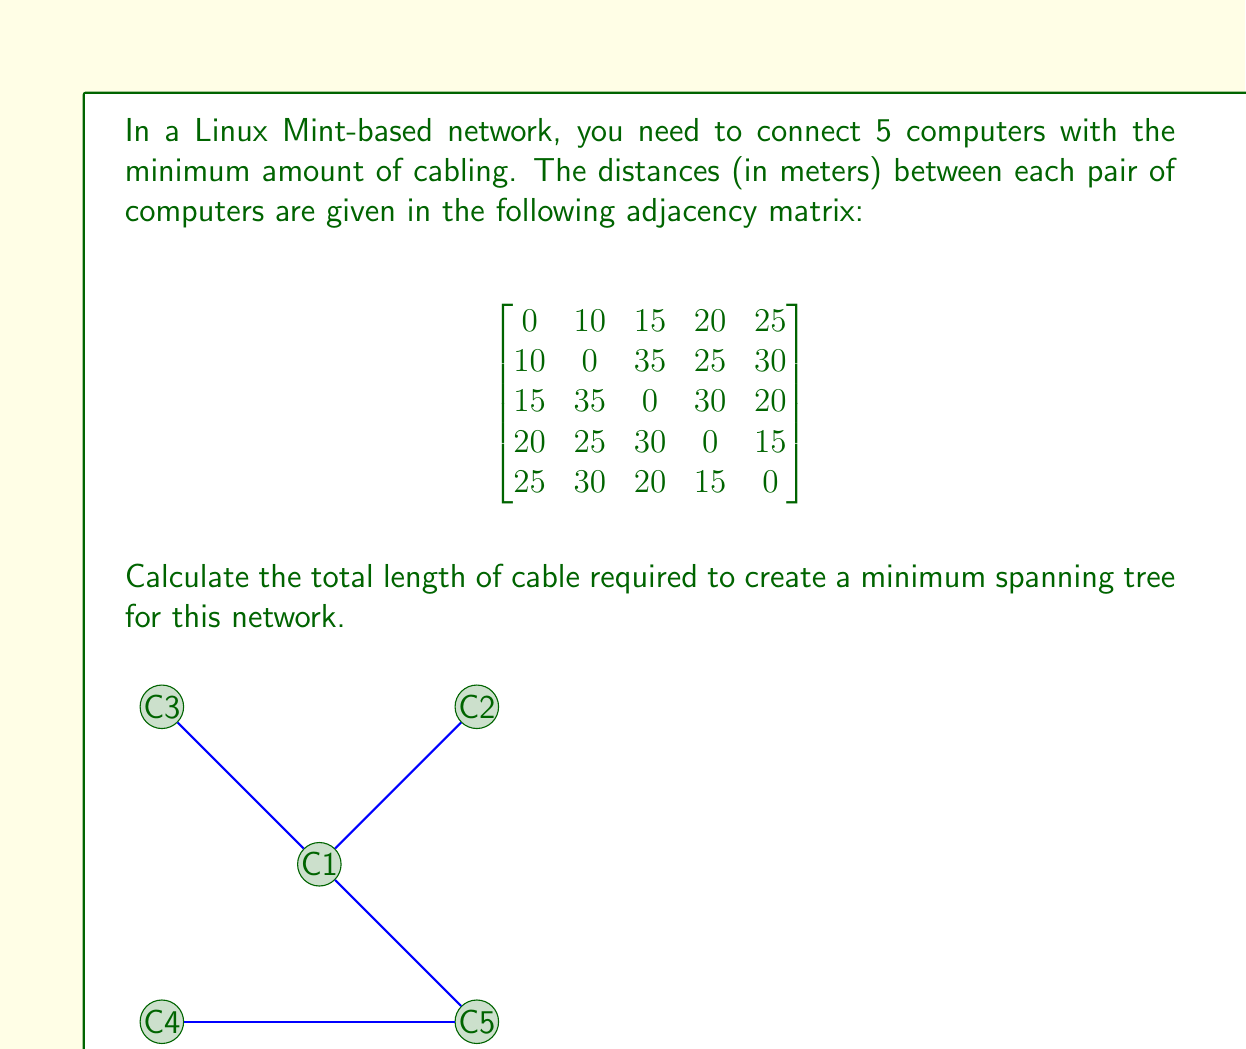Help me with this question. To solve this problem, we'll use Kruskal's algorithm to find the minimum spanning tree (MST) of the network. The algorithm works as follows:

1. Sort all edges in ascending order of weight (distance).
2. Start with an empty MST.
3. For each edge, starting from the smallest:
   a. If adding this edge doesn't create a cycle, add it to the MST.
   b. If it creates a cycle, skip it.
4. Continue until we have $n-1$ edges, where $n$ is the number of nodes.

Let's apply this to our network:

1. Sort the edges:
   C1-C2: 10m
   C1-C3: 15m
   C4-C5: 15m
   C1-C4: 20m
   C3-C5: 20m
   C1-C5: 25m
   C2-C4: 25m
   C2-C5: 30m
   C3-C4: 30m
   C2-C3: 35m

2. Start adding edges:
   - Add C1-C2 (10m)
   - Add C1-C3 (15m)
   - Add C4-C5 (15m)
   - Add C1-C4 (20m)

At this point, we have 4 edges (n-1, where n=5), so we stop.

The minimum spanning tree consists of these edges:
C1-C2, C1-C3, C4-C5, and C1-C4.

To calculate the total cable length, we sum the lengths of these edges:
$$10 + 15 + 15 + 20 = 60$$

Therefore, the total length of cable required is 60 meters.
Answer: 60 meters 